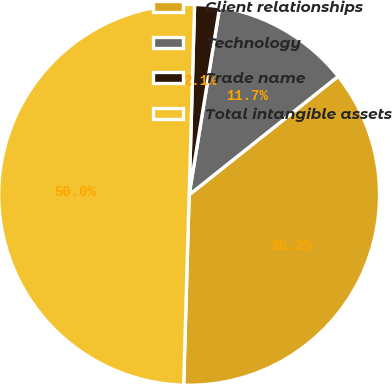Convert chart. <chart><loc_0><loc_0><loc_500><loc_500><pie_chart><fcel>Client relationships<fcel>Technology<fcel>Trade name<fcel>Total intangible assets<nl><fcel>36.15%<fcel>11.74%<fcel>2.11%<fcel>50.0%<nl></chart> 